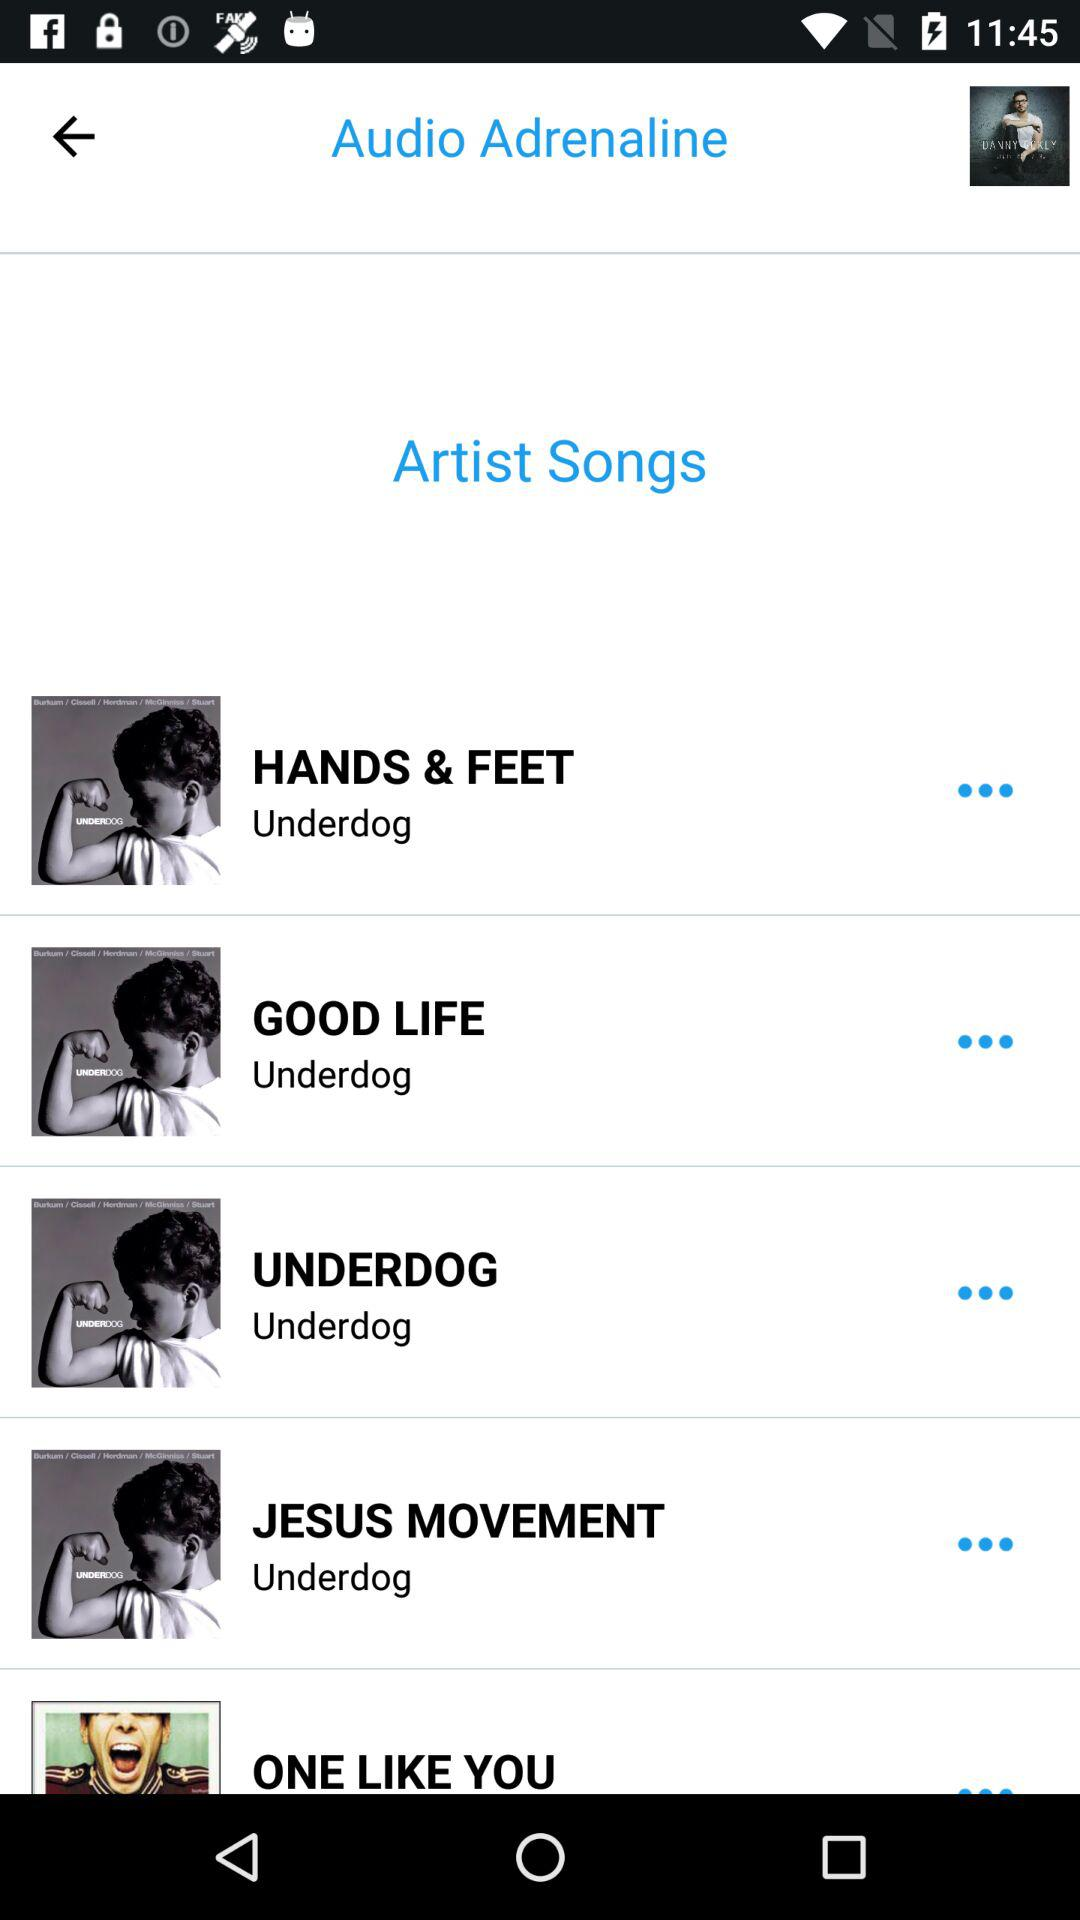Who sang the song "GOOD LIFE"? The song "GOOD LIFE" was sung by "Audio Adrenaline". 